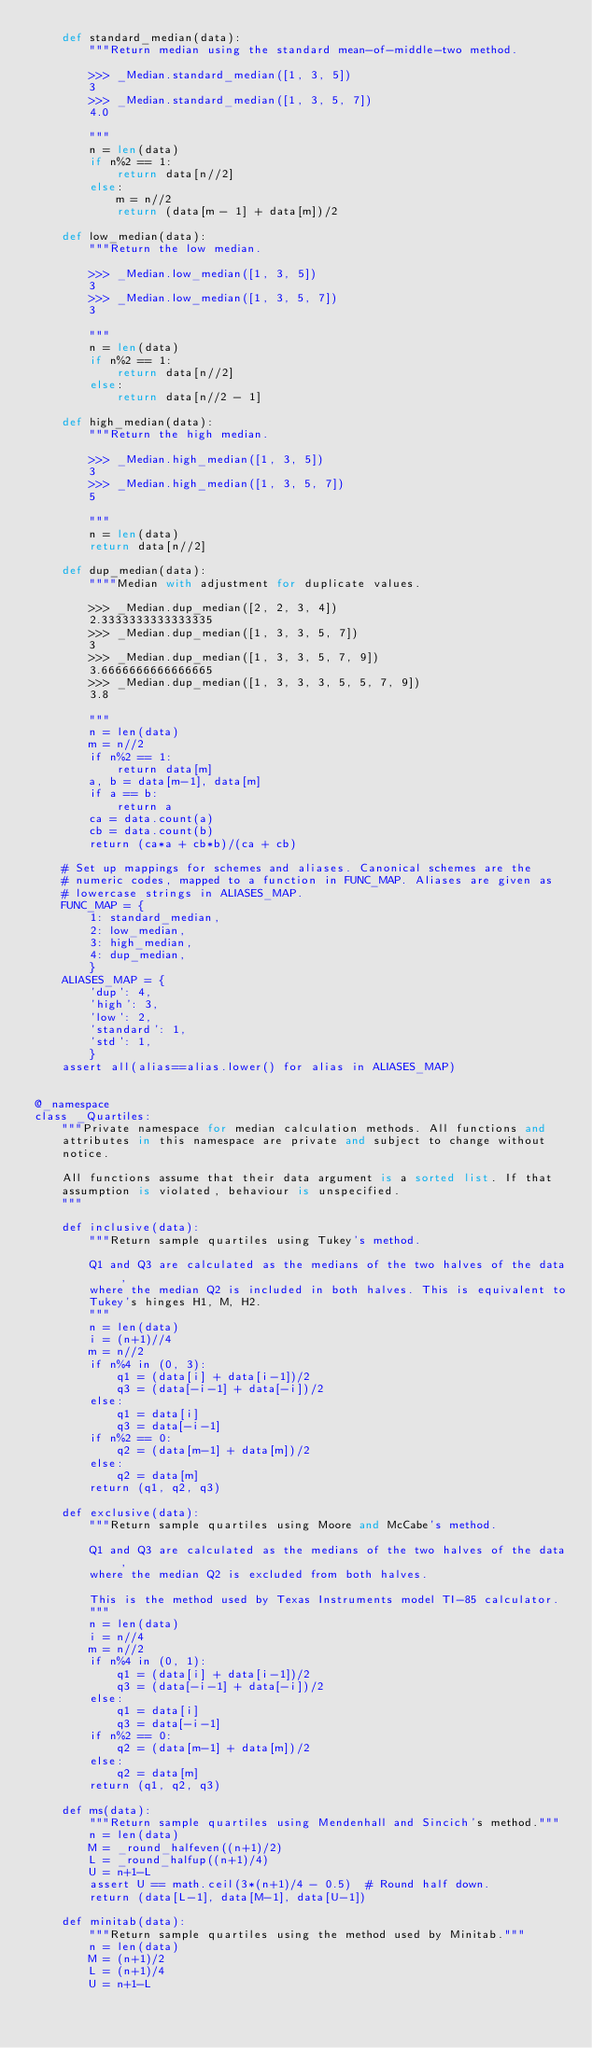<code> <loc_0><loc_0><loc_500><loc_500><_Python_>    def standard_median(data):
        """Return median using the standard mean-of-middle-two method.

        >>> _Median.standard_median([1, 3, 5])
        3
        >>> _Median.standard_median([1, 3, 5, 7])
        4.0

        """
        n = len(data)
        if n%2 == 1:
            return data[n//2]
        else:
            m = n//2
            return (data[m - 1] + data[m])/2

    def low_median(data):
        """Return the low median.

        >>> _Median.low_median([1, 3, 5])
        3
        >>> _Median.low_median([1, 3, 5, 7])
        3

        """
        n = len(data)
        if n%2 == 1:
            return data[n//2]
        else:
            return data[n//2 - 1]

    def high_median(data):
        """Return the high median.

        >>> _Median.high_median([1, 3, 5])
        3
        >>> _Median.high_median([1, 3, 5, 7])
        5

        """
        n = len(data)
        return data[n//2]

    def dup_median(data):
        """"Median with adjustment for duplicate values.

        >>> _Median.dup_median([2, 2, 3, 4])
        2.3333333333333335
        >>> _Median.dup_median([1, 3, 3, 5, 7])
        3
        >>> _Median.dup_median([1, 3, 3, 5, 7, 9])
        3.6666666666666665
        >>> _Median.dup_median([1, 3, 3, 3, 5, 5, 7, 9])
        3.8

        """
        n = len(data)
        m = n//2
        if n%2 == 1:
            return data[m]
        a, b = data[m-1], data[m]
        if a == b:
            return a
        ca = data.count(a)
        cb = data.count(b)
        return (ca*a + cb*b)/(ca + cb)

    # Set up mappings for schemes and aliases. Canonical schemes are the
    # numeric codes, mapped to a function in FUNC_MAP. Aliases are given as
    # lowercase strings in ALIASES_MAP.
    FUNC_MAP = {
        1: standard_median,
        2: low_median,
        3: high_median,
        4: dup_median,
        }
    ALIASES_MAP = {
        'dup': 4,
        'high': 3,
        'low': 2,
        'standard': 1,
        'std': 1,
        }
    assert all(alias==alias.lower() for alias in ALIASES_MAP)


@_namespace
class _Quartiles:
    """Private namespace for median calculation methods. All functions and
    attributes in this namespace are private and subject to change without
    notice.

    All functions assume that their data argument is a sorted list. If that
    assumption is violated, behaviour is unspecified.
    """

    def inclusive(data):
        """Return sample quartiles using Tukey's method.

        Q1 and Q3 are calculated as the medians of the two halves of the data,
        where the median Q2 is included in both halves. This is equivalent to
        Tukey's hinges H1, M, H2.
        """
        n = len(data)
        i = (n+1)//4
        m = n//2
        if n%4 in (0, 3):
            q1 = (data[i] + data[i-1])/2
            q3 = (data[-i-1] + data[-i])/2
        else:
            q1 = data[i]
            q3 = data[-i-1]
        if n%2 == 0:
            q2 = (data[m-1] + data[m])/2
        else:
            q2 = data[m]
        return (q1, q2, q3)

    def exclusive(data):
        """Return sample quartiles using Moore and McCabe's method.

        Q1 and Q3 are calculated as the medians of the two halves of the data,
        where the median Q2 is excluded from both halves.

        This is the method used by Texas Instruments model TI-85 calculator.
        """
        n = len(data)
        i = n//4
        m = n//2
        if n%4 in (0, 1):
            q1 = (data[i] + data[i-1])/2
            q3 = (data[-i-1] + data[-i])/2
        else:
            q1 = data[i]
            q3 = data[-i-1]
        if n%2 == 0:
            q2 = (data[m-1] + data[m])/2
        else:
            q2 = data[m]
        return (q1, q2, q3)

    def ms(data):
        """Return sample quartiles using Mendenhall and Sincich's method."""
        n = len(data)
        M = _round_halfeven((n+1)/2)
        L = _round_halfup((n+1)/4)
        U = n+1-L
        assert U == math.ceil(3*(n+1)/4 - 0.5)  # Round half down.
        return (data[L-1], data[M-1], data[U-1])

    def minitab(data):
        """Return sample quartiles using the method used by Minitab."""
        n = len(data)
        M = (n+1)/2
        L = (n+1)/4
        U = n+1-L</code> 